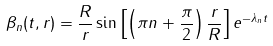<formula> <loc_0><loc_0><loc_500><loc_500>\beta _ { n } ( t , r ) = \frac { R } { r } \sin \left [ \left ( \pi n + \frac { \pi } { 2 } \right ) \frac { r } { R } \right ] e ^ { - \lambda _ { n } t }</formula> 